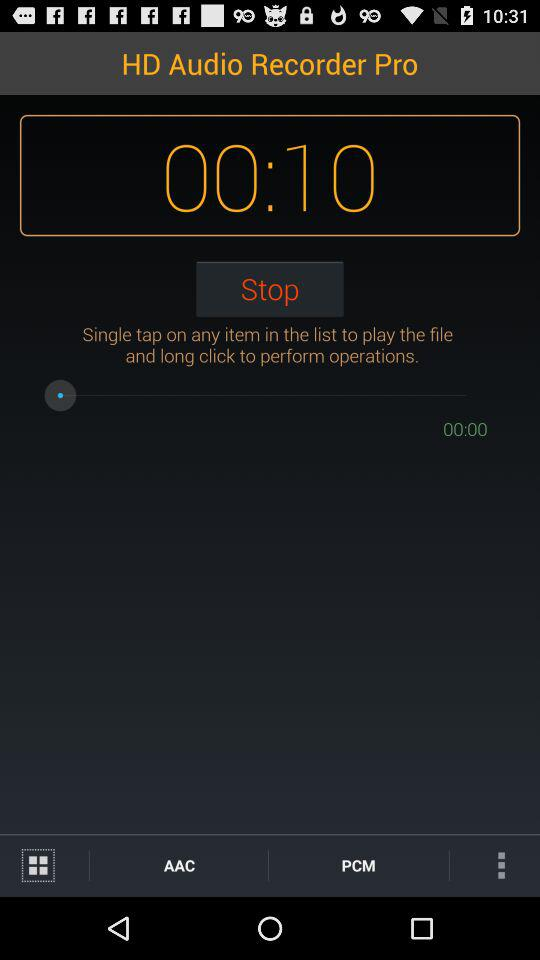What is the mentioned duration? The mentioned duration is 10 seconds. 